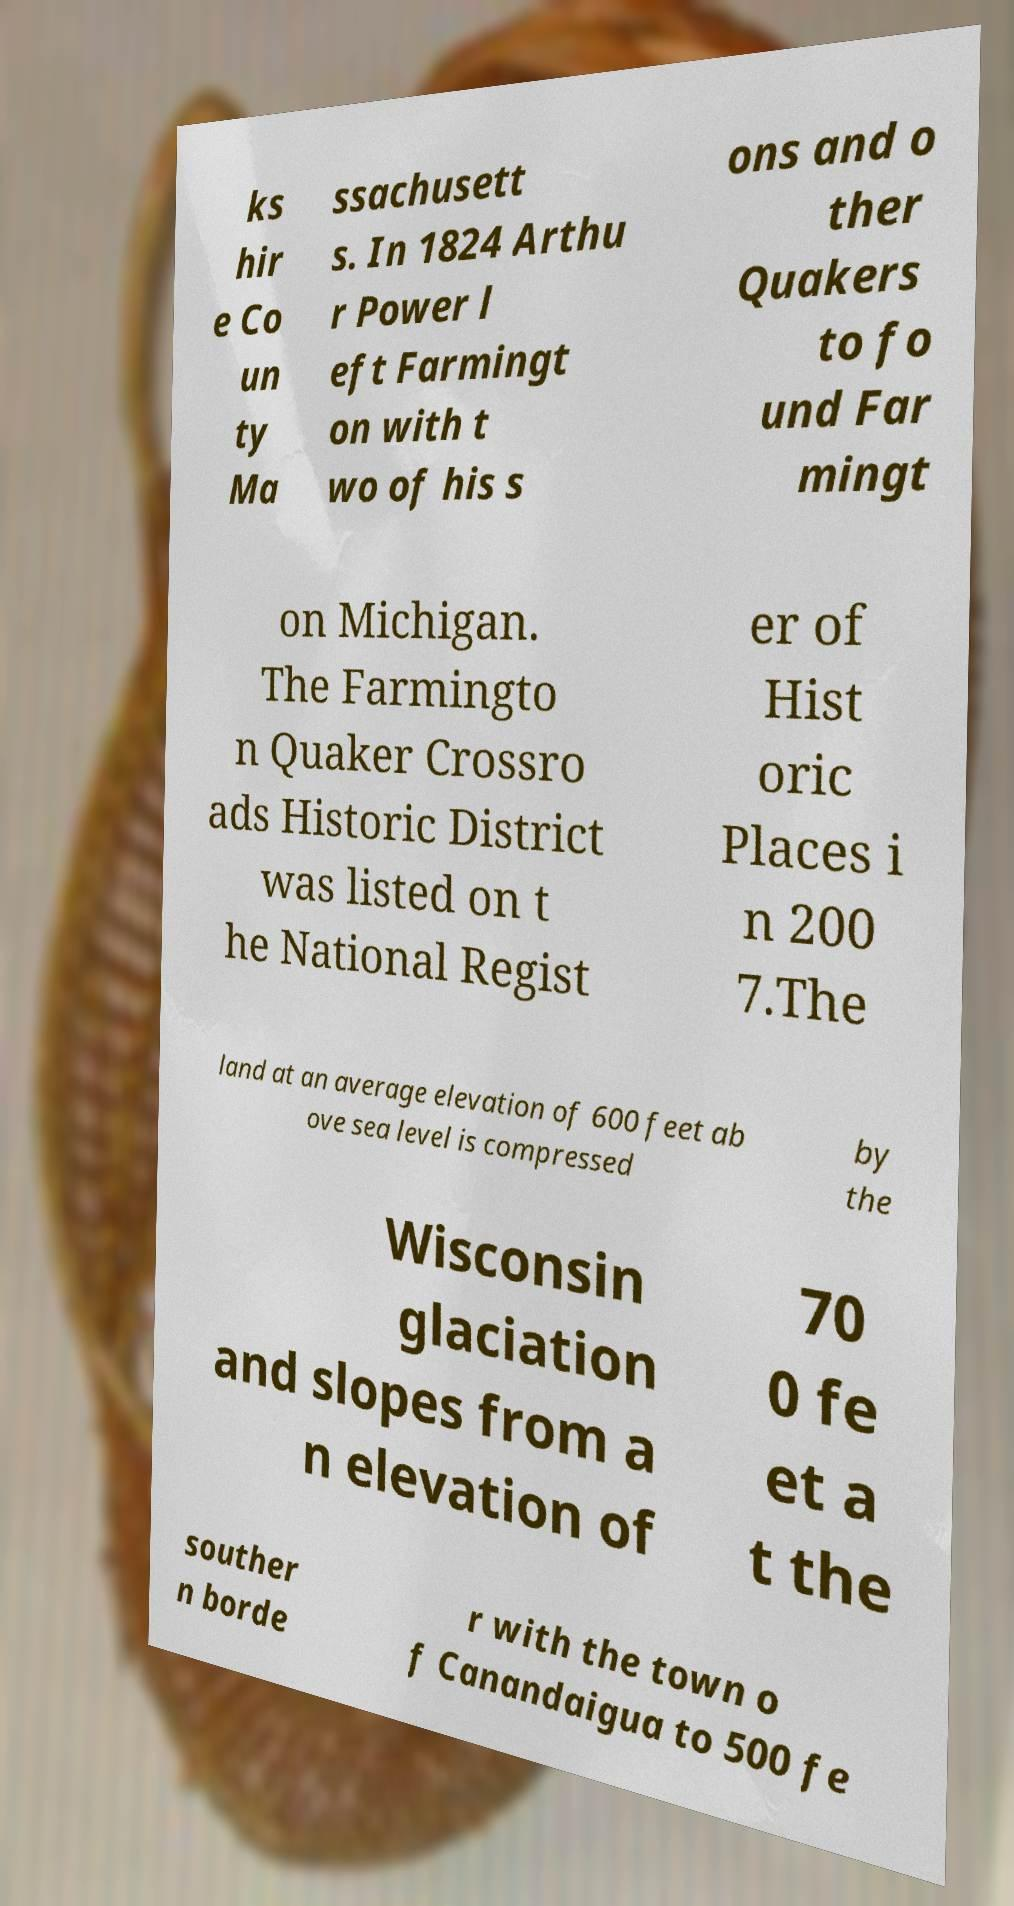For documentation purposes, I need the text within this image transcribed. Could you provide that? ks hir e Co un ty Ma ssachusett s. In 1824 Arthu r Power l eft Farmingt on with t wo of his s ons and o ther Quakers to fo und Far mingt on Michigan. The Farmingto n Quaker Crossro ads Historic District was listed on t he National Regist er of Hist oric Places i n 200 7.The land at an average elevation of 600 feet ab ove sea level is compressed by the Wisconsin glaciation and slopes from a n elevation of 70 0 fe et a t the souther n borde r with the town o f Canandaigua to 500 fe 